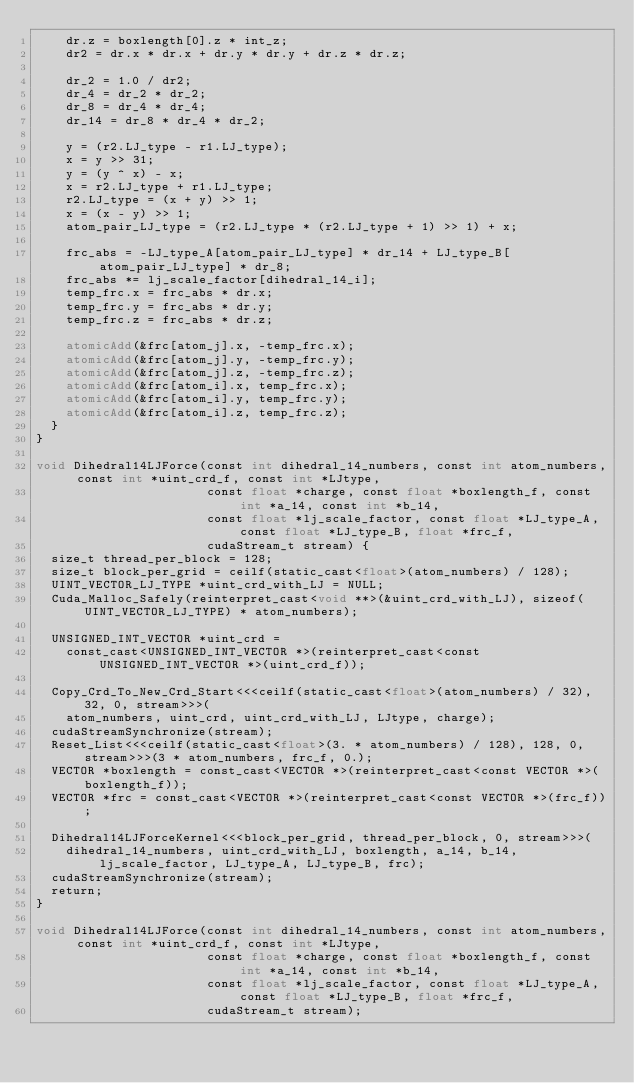Convert code to text. <code><loc_0><loc_0><loc_500><loc_500><_Cuda_>    dr.z = boxlength[0].z * int_z;
    dr2 = dr.x * dr.x + dr.y * dr.y + dr.z * dr.z;

    dr_2 = 1.0 / dr2;
    dr_4 = dr_2 * dr_2;
    dr_8 = dr_4 * dr_4;
    dr_14 = dr_8 * dr_4 * dr_2;

    y = (r2.LJ_type - r1.LJ_type);
    x = y >> 31;
    y = (y ^ x) - x;
    x = r2.LJ_type + r1.LJ_type;
    r2.LJ_type = (x + y) >> 1;
    x = (x - y) >> 1;
    atom_pair_LJ_type = (r2.LJ_type * (r2.LJ_type + 1) >> 1) + x;

    frc_abs = -LJ_type_A[atom_pair_LJ_type] * dr_14 + LJ_type_B[atom_pair_LJ_type] * dr_8;
    frc_abs *= lj_scale_factor[dihedral_14_i];
    temp_frc.x = frc_abs * dr.x;
    temp_frc.y = frc_abs * dr.y;
    temp_frc.z = frc_abs * dr.z;

    atomicAdd(&frc[atom_j].x, -temp_frc.x);
    atomicAdd(&frc[atom_j].y, -temp_frc.y);
    atomicAdd(&frc[atom_j].z, -temp_frc.z);
    atomicAdd(&frc[atom_i].x, temp_frc.x);
    atomicAdd(&frc[atom_i].y, temp_frc.y);
    atomicAdd(&frc[atom_i].z, temp_frc.z);
  }
}

void Dihedral14LJForce(const int dihedral_14_numbers, const int atom_numbers, const int *uint_crd_f, const int *LJtype,
                       const float *charge, const float *boxlength_f, const int *a_14, const int *b_14,
                       const float *lj_scale_factor, const float *LJ_type_A, const float *LJ_type_B, float *frc_f,
                       cudaStream_t stream) {
  size_t thread_per_block = 128;
  size_t block_per_grid = ceilf(static_cast<float>(atom_numbers) / 128);
  UINT_VECTOR_LJ_TYPE *uint_crd_with_LJ = NULL;
  Cuda_Malloc_Safely(reinterpret_cast<void **>(&uint_crd_with_LJ), sizeof(UINT_VECTOR_LJ_TYPE) * atom_numbers);

  UNSIGNED_INT_VECTOR *uint_crd =
    const_cast<UNSIGNED_INT_VECTOR *>(reinterpret_cast<const UNSIGNED_INT_VECTOR *>(uint_crd_f));

  Copy_Crd_To_New_Crd_Start<<<ceilf(static_cast<float>(atom_numbers) / 32), 32, 0, stream>>>(
    atom_numbers, uint_crd, uint_crd_with_LJ, LJtype, charge);
  cudaStreamSynchronize(stream);
  Reset_List<<<ceilf(static_cast<float>(3. * atom_numbers) / 128), 128, 0, stream>>>(3 * atom_numbers, frc_f, 0.);
  VECTOR *boxlength = const_cast<VECTOR *>(reinterpret_cast<const VECTOR *>(boxlength_f));
  VECTOR *frc = const_cast<VECTOR *>(reinterpret_cast<const VECTOR *>(frc_f));

  Dihedral14LJForceKernel<<<block_per_grid, thread_per_block, 0, stream>>>(
    dihedral_14_numbers, uint_crd_with_LJ, boxlength, a_14, b_14, lj_scale_factor, LJ_type_A, LJ_type_B, frc);
  cudaStreamSynchronize(stream);
  return;
}

void Dihedral14LJForce(const int dihedral_14_numbers, const int atom_numbers, const int *uint_crd_f, const int *LJtype,
                       const float *charge, const float *boxlength_f, const int *a_14, const int *b_14,
                       const float *lj_scale_factor, const float *LJ_type_A, const float *LJ_type_B, float *frc_f,
                       cudaStream_t stream);
</code> 